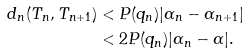<formula> <loc_0><loc_0><loc_500><loc_500>d _ { n } ( T _ { n } , T _ { n + 1 } ) & < P ( q _ { n } ) | \alpha _ { n } - \alpha _ { n + 1 } | \\ & < 2 P ( q _ { n } ) | \alpha _ { n } - \alpha | .</formula> 